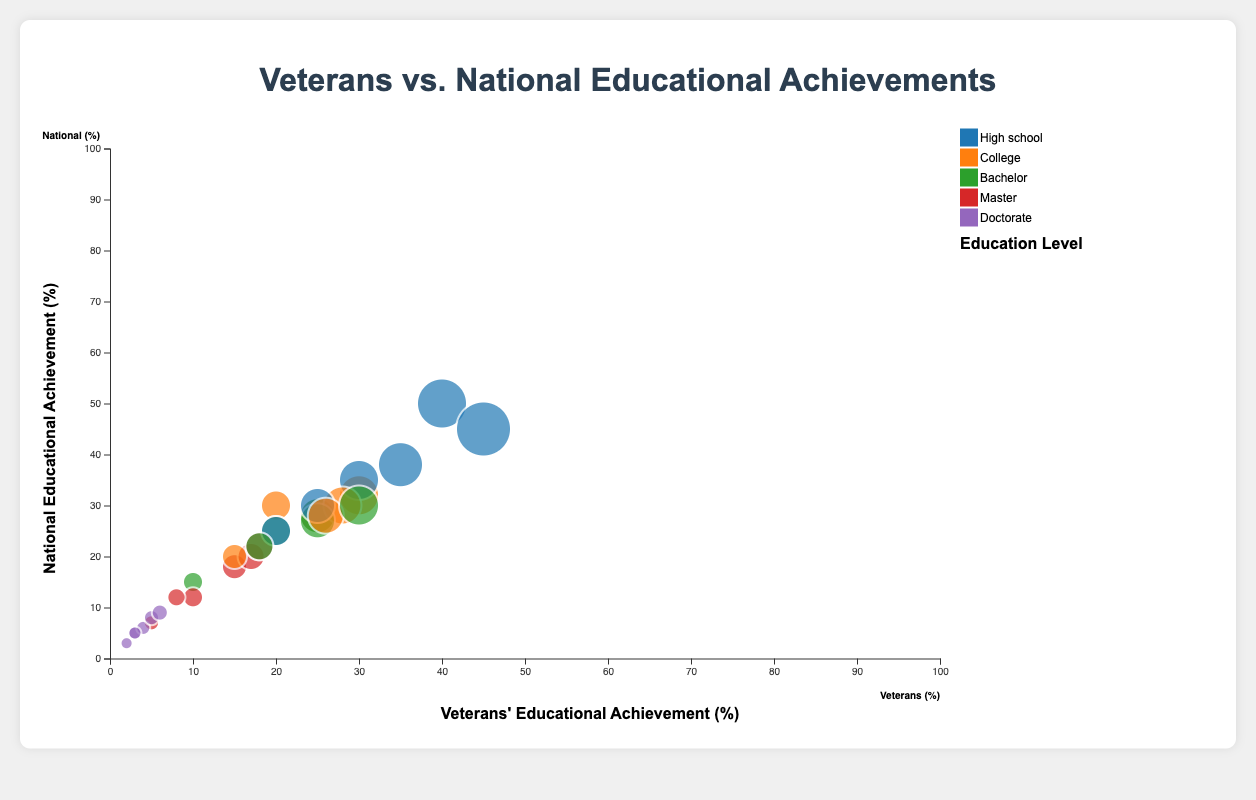What's the title of the figure? The title can be found at the top center of the figure. It summarizes the content of the chart.
Answer: "Veterans vs. National Educational Achievements" How are the educational levels represented in the figure? The educational levels are differentiated by colors in the chart. Each color corresponds to a specific educational level.
Answer: By different colors for each educational level Which age group has the highest percentage of veterans with a master's degree? To find this, look for the circle with the largest size filled with the color representing a master's degree across age groups.
Answer: 55-64 Which educational level has a consistently lower percentage for veterans compared to the national average across most age groups? Compare each educational level's circles for veterans and the national average across all age groups. The circles for veterans being consistently smaller indicates a lower percentage.
Answer: Doctorate Compare the percentage of veterans and national averages with a bachelor's degree in the 25-34 age group. Locate the relevant circles for the 25-34 age group (one for veterans and one for the national average) and compare their sizes and positions.
Answer: Veterans: 20%, National: 25% Which age group shows the smallest difference between veterans and national averages for high school education? Look for the high school education circles closest to each other across age groups to find the smallest difference.
Answer: 25-34 How does the percentage of veterans with a high school education change from the 18-24 age group to the 65+ age group? Track the high school education circles from 18-24 to 65+, noting the percentage values indicated by their positions or sizes.
Answer: Decreases from 40% to 20% What does the y-axis represent in this figure? The y-axis, which runs vertically, indicates the national average percentage for educational achievements.
Answer: National average percentage Compare the percentage of veterans with a bachelor's degree in the 35-44 and 45-54 age groups. Identify the circles for the bachelor's degree in the respective age groups and note their percentages.
Answer: 35-44: 25%, 45-54: 25% What trend can you observe for veterans with a college education across different age groups? Examine the positions and sizes of the circles representing college education for veterans across age groups to identify any trends.
Answer: The percentage mostly increases from the 18-24 age group to the 45-54 age group and declines in older groups 